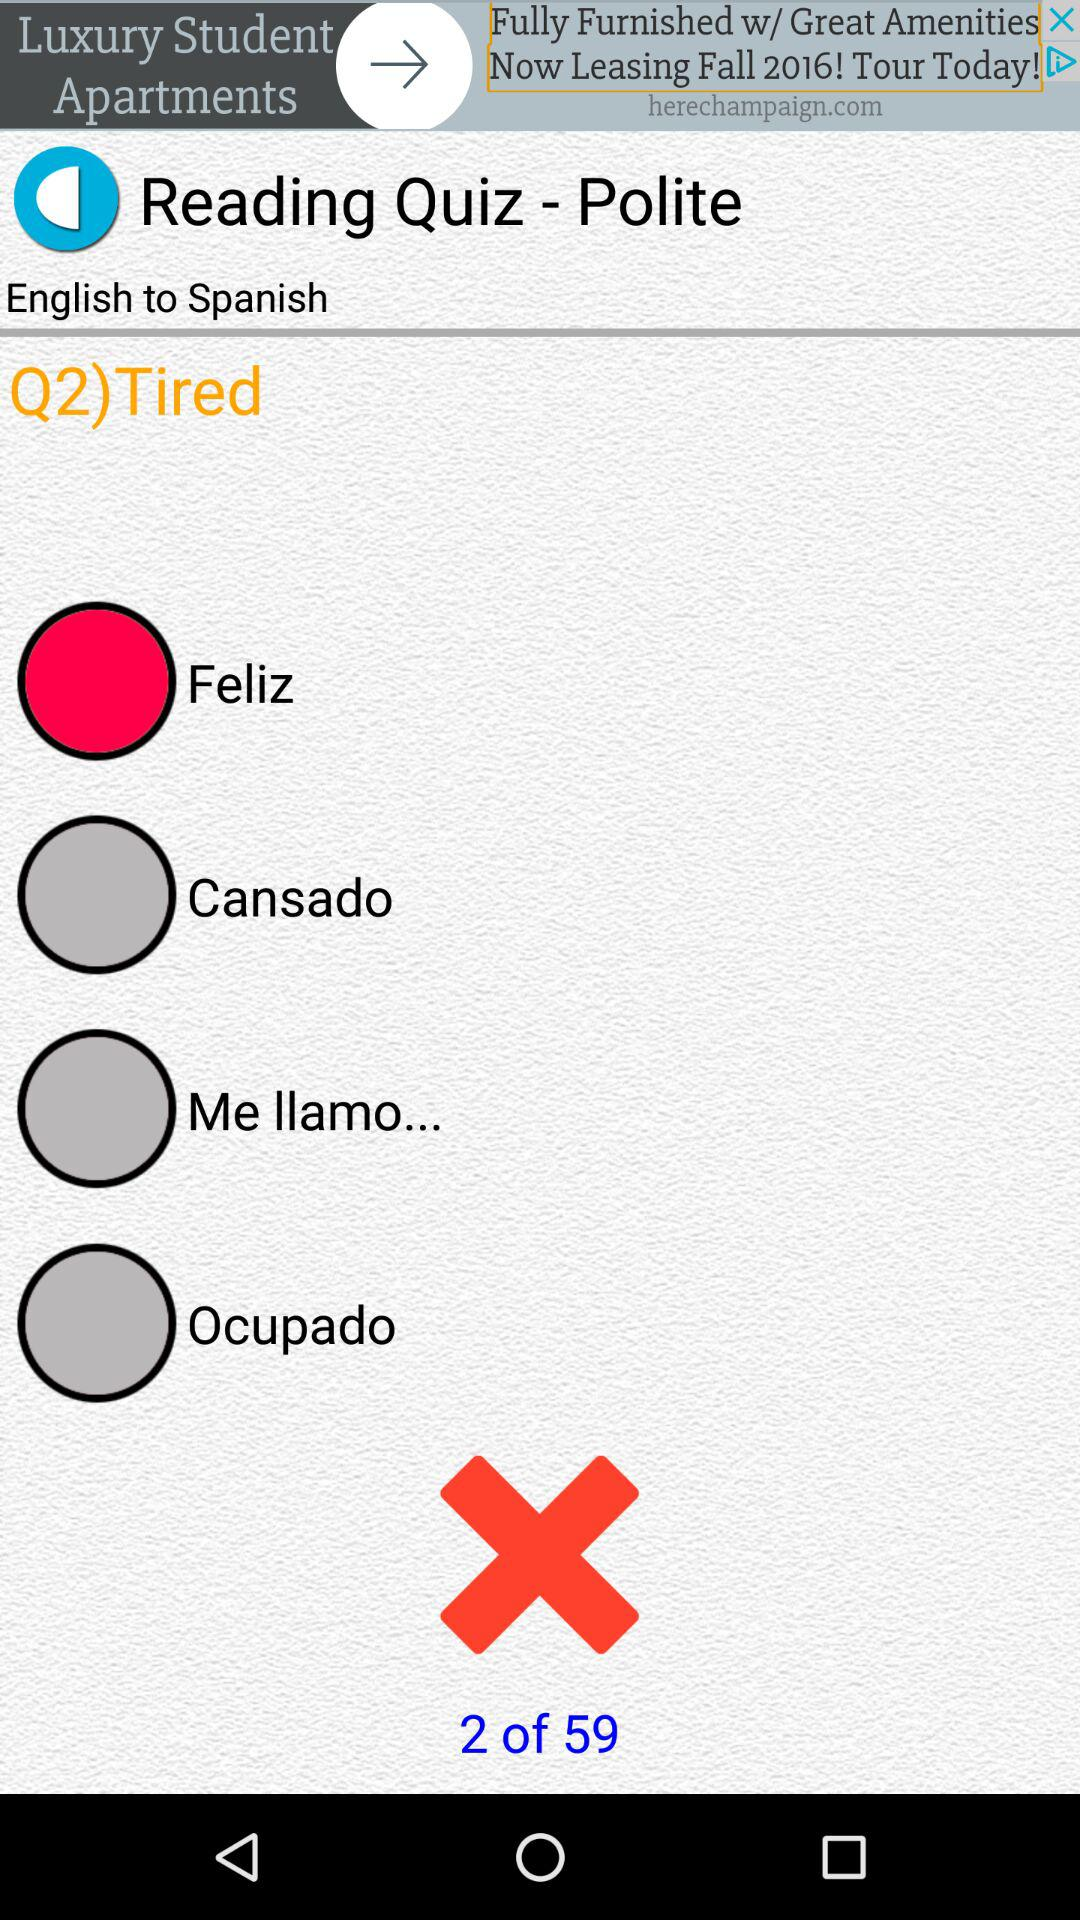What is the question? The question is "Tired". 